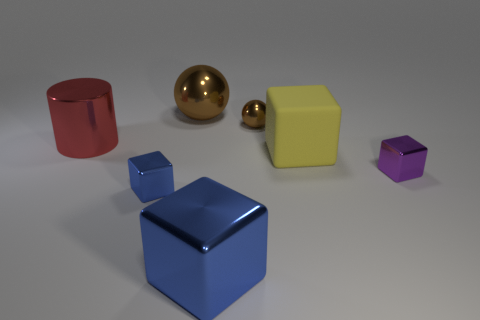There is another metallic ball that is the same color as the large sphere; what is its size?
Ensure brevity in your answer.  Small. What shape is the metal object that is the same color as the big metallic block?
Your response must be concise. Cube. How big is the matte thing in front of the large sphere behind the tiny metallic object behind the big metallic cylinder?
Your response must be concise. Large. There is a brown metallic thing that is right of the large metal object behind the red metal cylinder; what shape is it?
Ensure brevity in your answer.  Sphere. Is the number of big metal things that are behind the large matte thing greater than the number of big blue matte balls?
Offer a terse response. Yes. Do the small thing that is behind the red metal cylinder and the large brown object have the same shape?
Make the answer very short. Yes. Are there any tiny purple metallic things that have the same shape as the big blue metal object?
Offer a terse response. Yes. How many objects are large cubes that are behind the small purple shiny cube or tiny red matte things?
Provide a succinct answer. 1. Are there more large shiny things than big brown matte cubes?
Give a very brief answer. Yes. Are there any cylinders of the same size as the yellow thing?
Provide a succinct answer. Yes. 